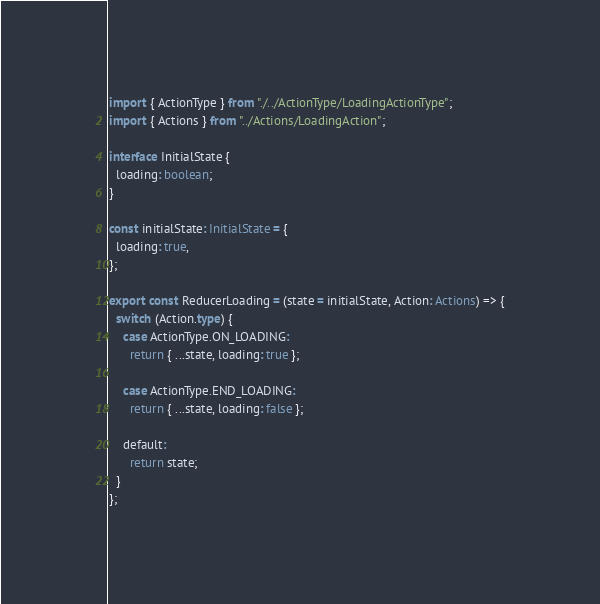Convert code to text. <code><loc_0><loc_0><loc_500><loc_500><_TypeScript_>import { ActionType } from "./../ActionType/LoadingActionType";
import { Actions } from "../Actions/LoadingAction";

interface InitialState {
  loading: boolean;
}

const initialState: InitialState = {
  loading: true,
};

export const ReducerLoading = (state = initialState, Action: Actions) => {
  switch (Action.type) {
    case ActionType.ON_LOADING:
      return { ...state, loading: true };

    case ActionType.END_LOADING:
      return { ...state, loading: false };

    default:
      return state;
  }
};
</code> 